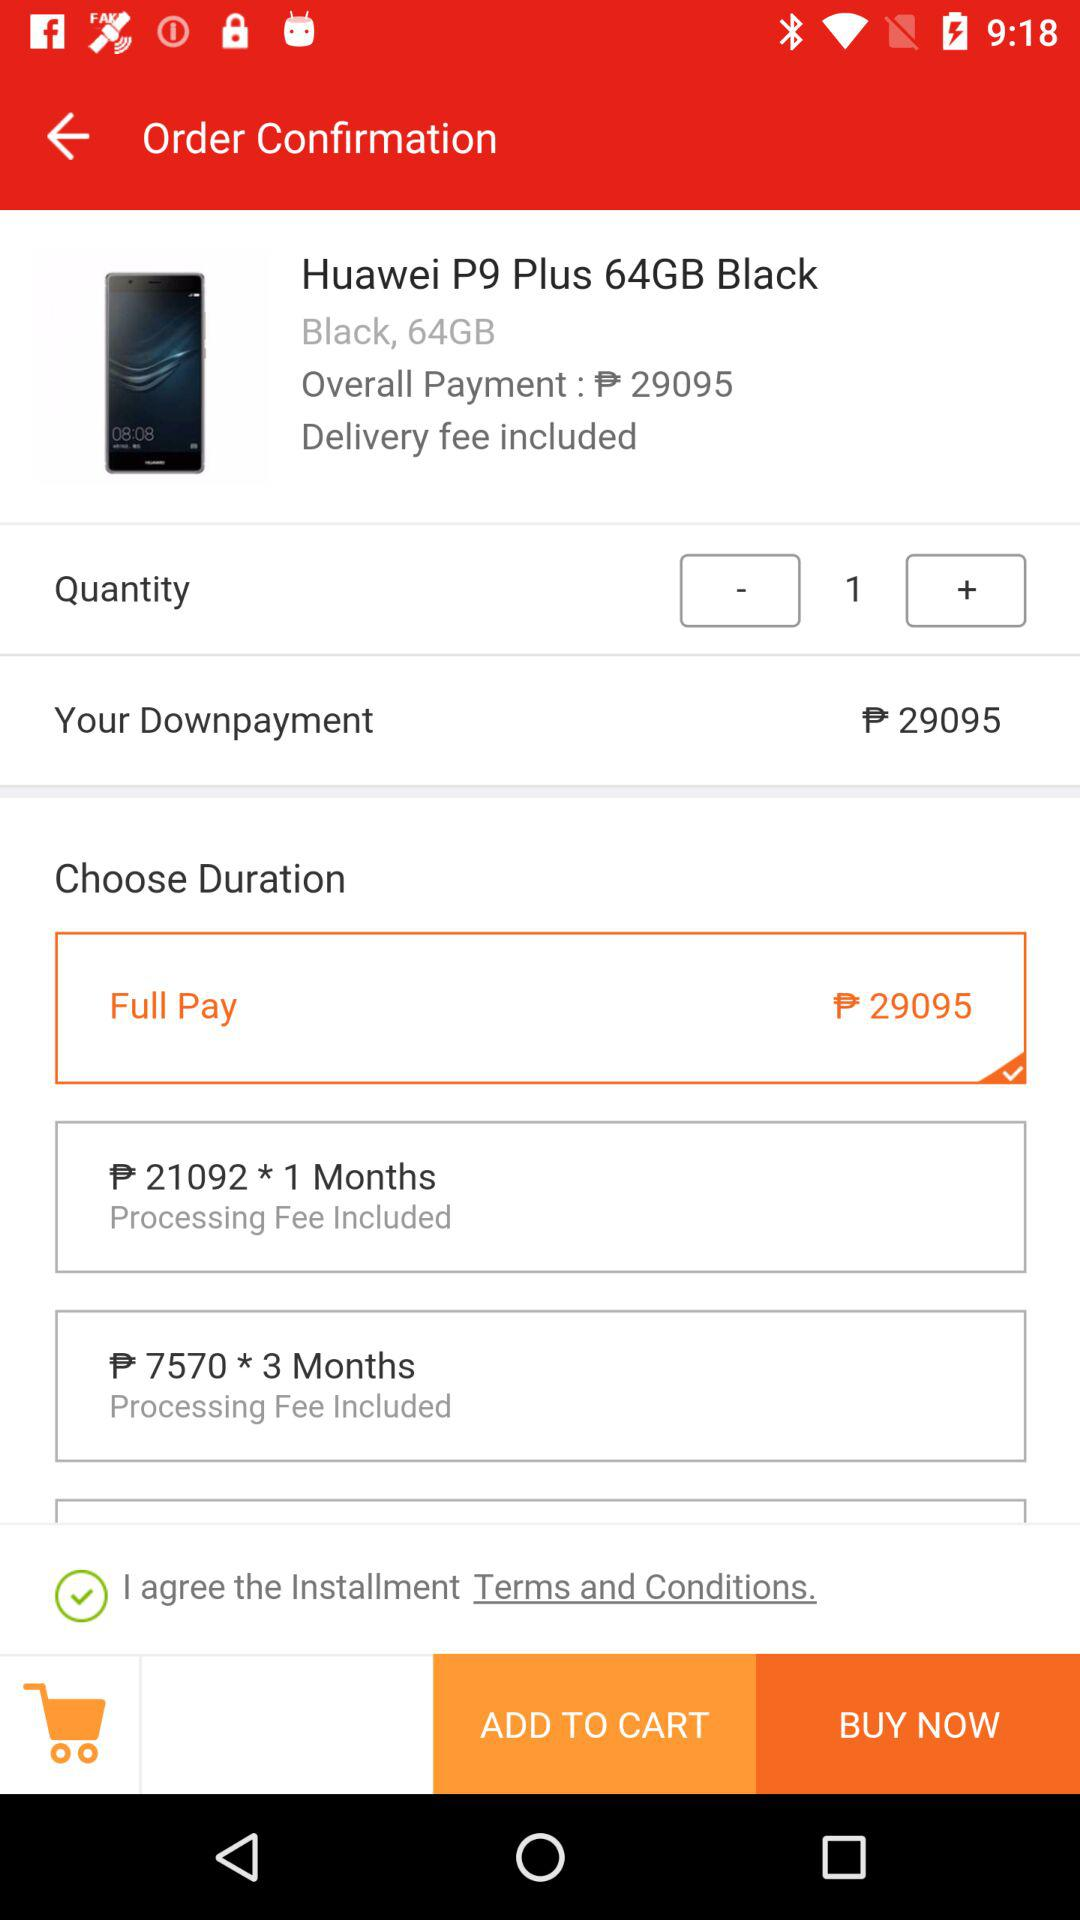How much is the down payment? The down payment is ₱ 29095. 